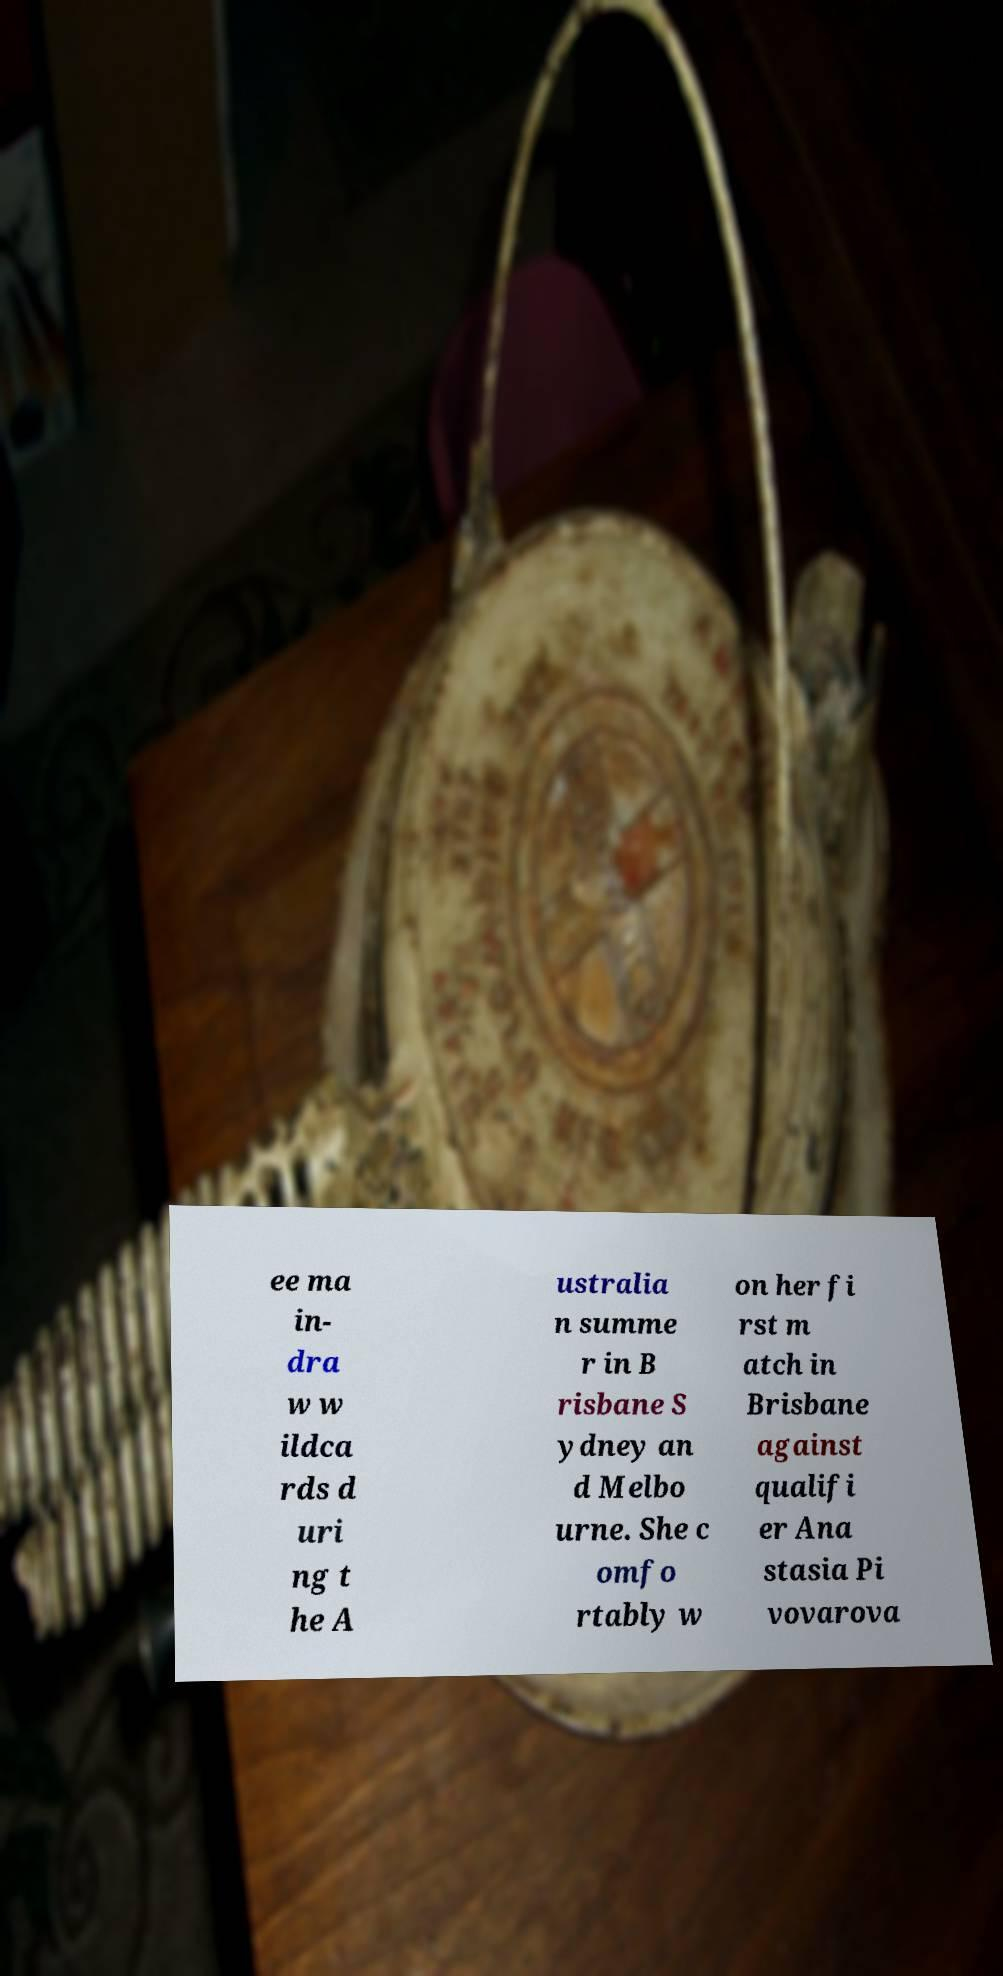Can you accurately transcribe the text from the provided image for me? ee ma in- dra w w ildca rds d uri ng t he A ustralia n summe r in B risbane S ydney an d Melbo urne. She c omfo rtably w on her fi rst m atch in Brisbane against qualifi er Ana stasia Pi vovarova 